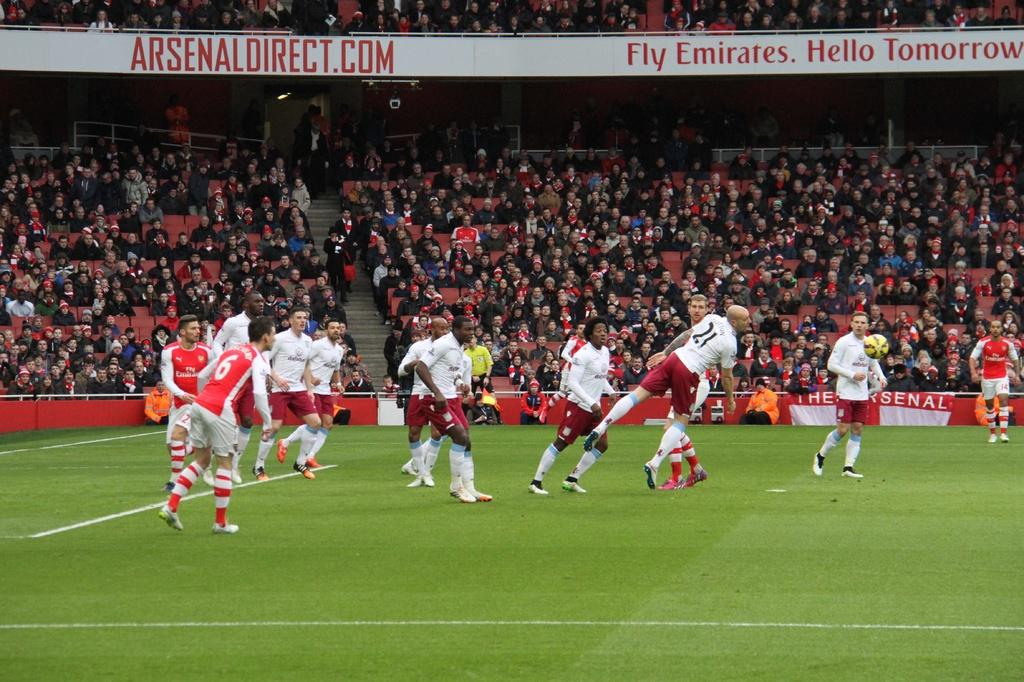What are the people in the image doing? There is a group of people sitting in the image. What type of activity might they be participating in? There are players visible in the image, which suggests they might be playing a game or sport. What object is present that is commonly used in such activities? There is a ball in the image. Is there any additional information provided by the banner in the image? Yes, there is a banner attached to the railing in the image. What type of waves can be seen crashing on the shore in the image? There are no waves visible in the image; it features a group of people sitting with players and a ball. How does the mitten help the players in the image? There is no mitten present in the image, so it cannot help the players. 